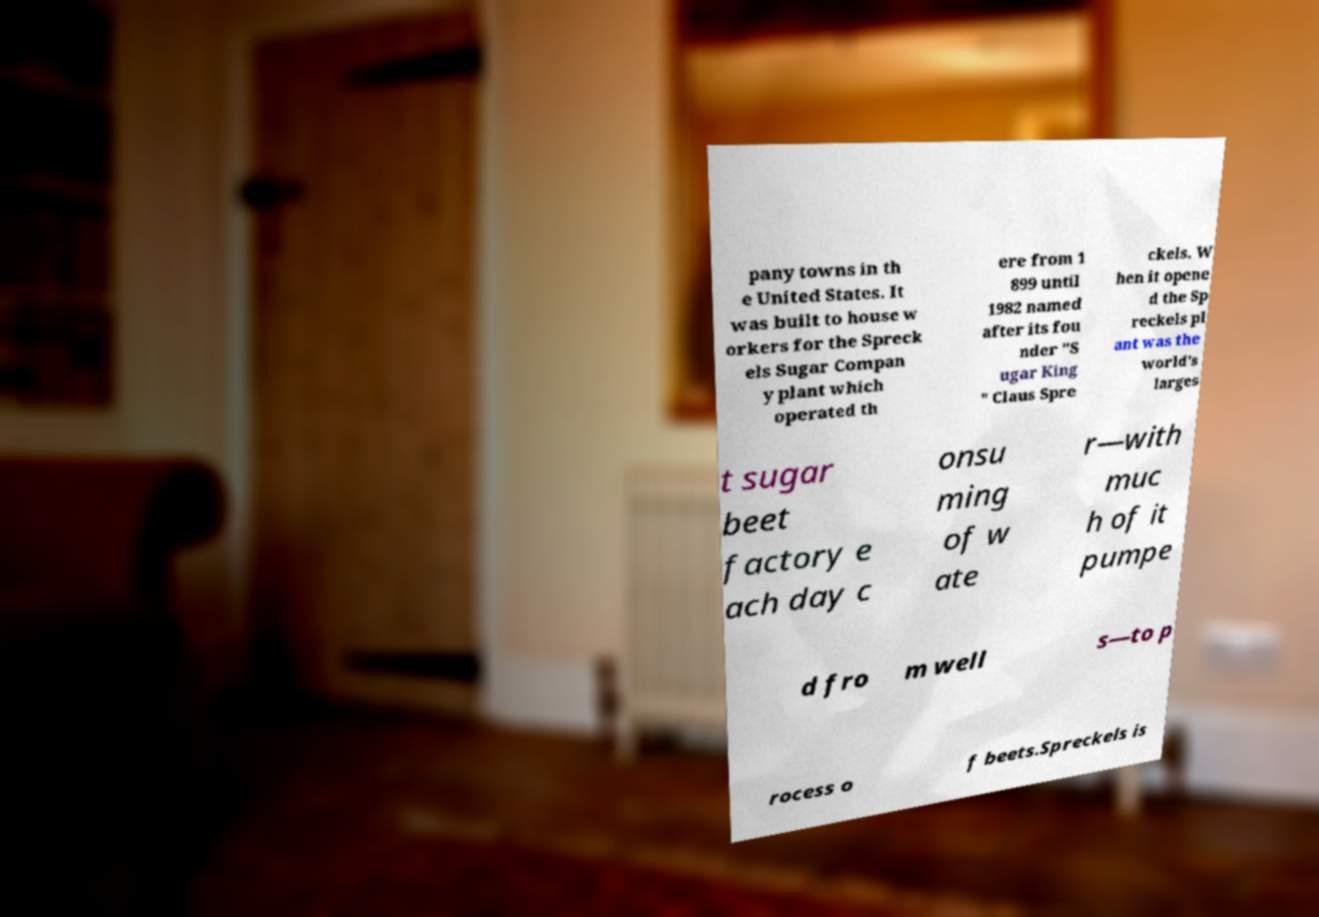Can you read and provide the text displayed in the image?This photo seems to have some interesting text. Can you extract and type it out for me? pany towns in th e United States. It was built to house w orkers for the Spreck els Sugar Compan y plant which operated th ere from 1 899 until 1982 named after its fou nder "S ugar King " Claus Spre ckels. W hen it opene d the Sp reckels pl ant was the world's larges t sugar beet factory e ach day c onsu ming of w ate r—with muc h of it pumpe d fro m well s—to p rocess o f beets.Spreckels is 